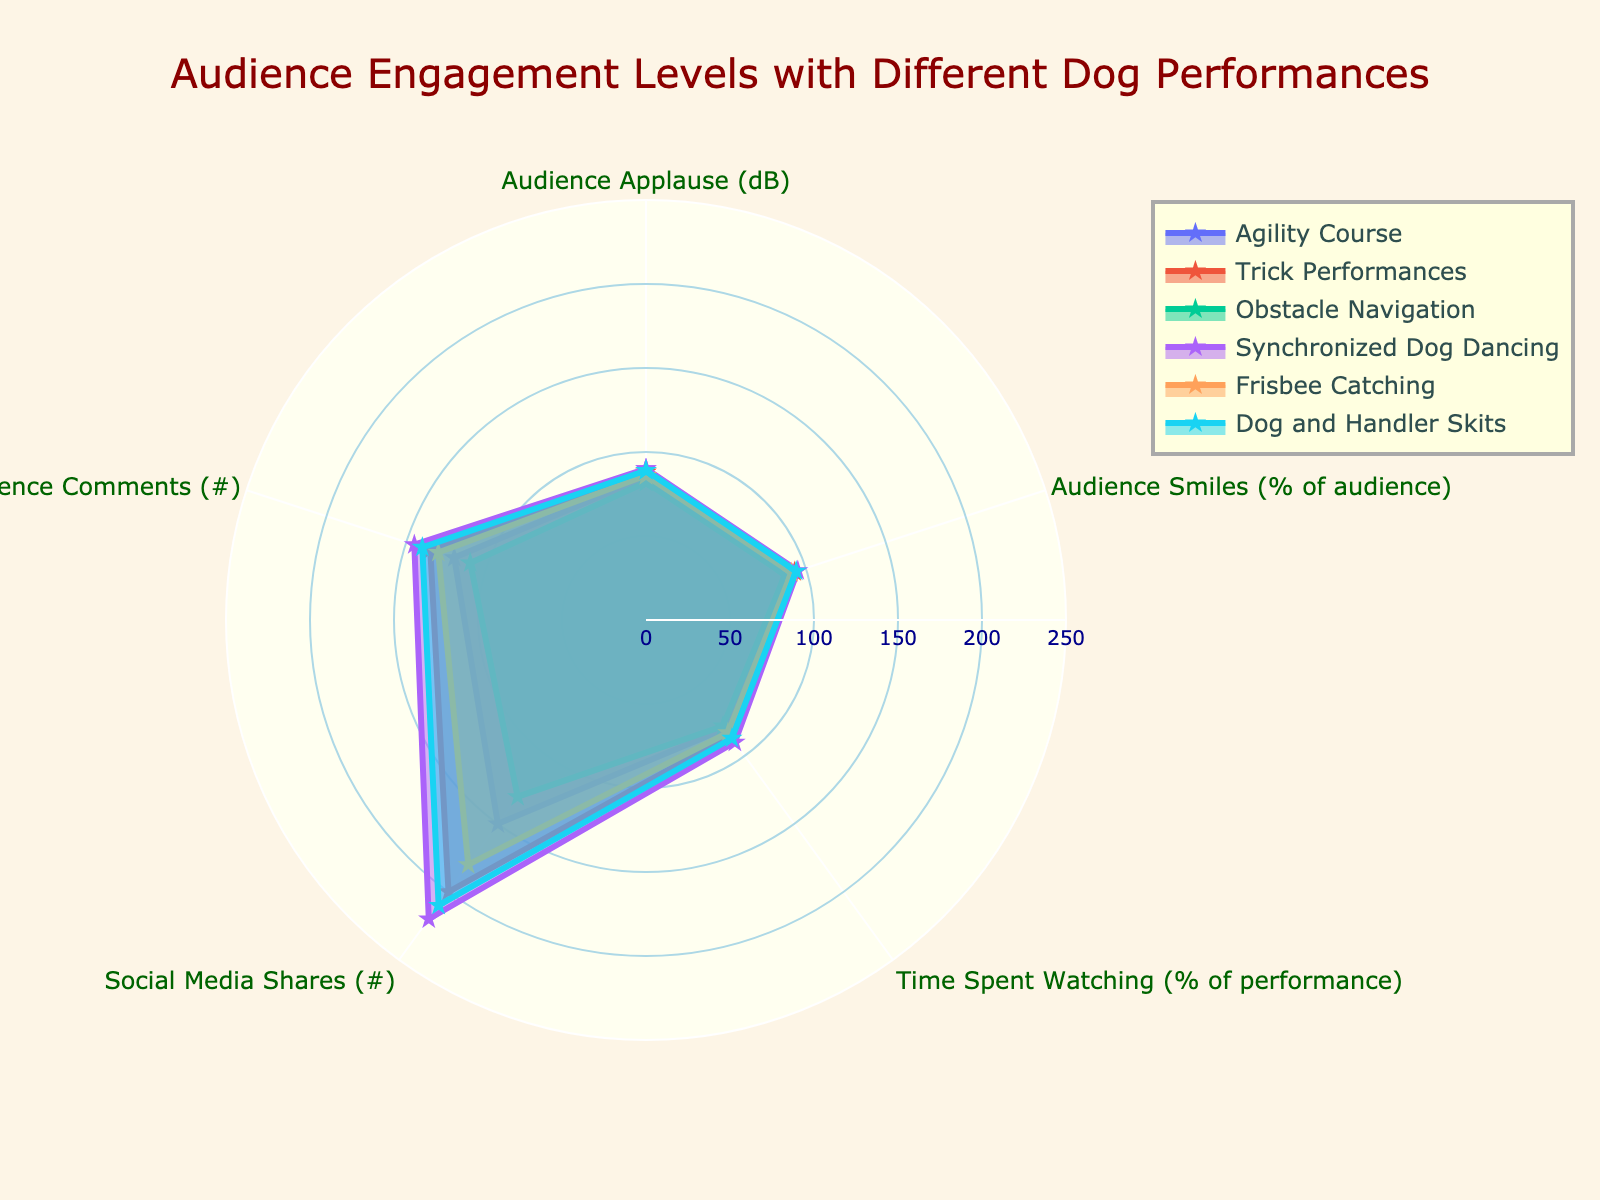What's the title of the chart? The title is prominently displayed at the top of the chart. It summarizes what the chart is about.
Answer: Audience Engagement Levels with Different Dog Performances How many performance types are shown in the chart? By counting the number of different performance names in the legend, you can determine the number of performance types.
Answer: 6 Which performance type received the highest social media shares? By examining the social media shares metric, you can identify that the performance with the highest value in that category is the one to look for.
Answer: Synchronized Dog Dancing What is the average audience applause (dB) level for all performance types? To find the average, sum up the audience applause levels for all performance types and divide by the number of performance types. (85 + 88 + 82 + 90 + 86 + 89) / 6 = 520 / 6
Answer: 86.67 Which performance type had the lowest time spent watching (% of performance)? By identifying the performance type with the smallest value in the time spent watching category, you can determine which one had the lowest engagement in this aspect.
Answer: Obstacle Navigation What is the difference in audience comments between Synchronized Dog Dancing and Agility Course? Subtract the number of comments for Agility Course from those for Synchronized Dog Dancing: 145 - 120 = 25.
Answer: 25 If you had to choose one performance type based on the highest audience smiles and time spent watching, which would it be? By identifying the performance type that scores highest in both audience smiles and time spent watching, you can make an informed choice.
Answer: Synchronized Dog Dancing How does the Audience Applause for Trick Performances compare to that of Frisbee Catching? Both these performance types' applause levels are visible in the chart. Comparing these values, we see that Trick Performances have a higher audience applause level than Frisbee Catching: 88 vs 86.
Answer: Trick Performances Which category (metric) had the highest value across all performance types? By scanning through each category for all performance types, you notice that Social Media Shares for Synchronized Dog Dancing reaches 220, which is the highest value observed.
Answer: Social Media Shares Which performance type has the most engagement across all metrics combined? By summing the values for all metrics of each performance type and comparing them, you can identify the top-performing one. Calculating the sums: Agility Course (525), Trick Performances (701), Obstacle Navigation (487), Synchronized Dog Dancing (750), Frisbee Catching (670), Dog and Handler Skits (720). So, Synchronized Dog Dancing has the most engagement.
Answer: Synchronized Dog Dancing 